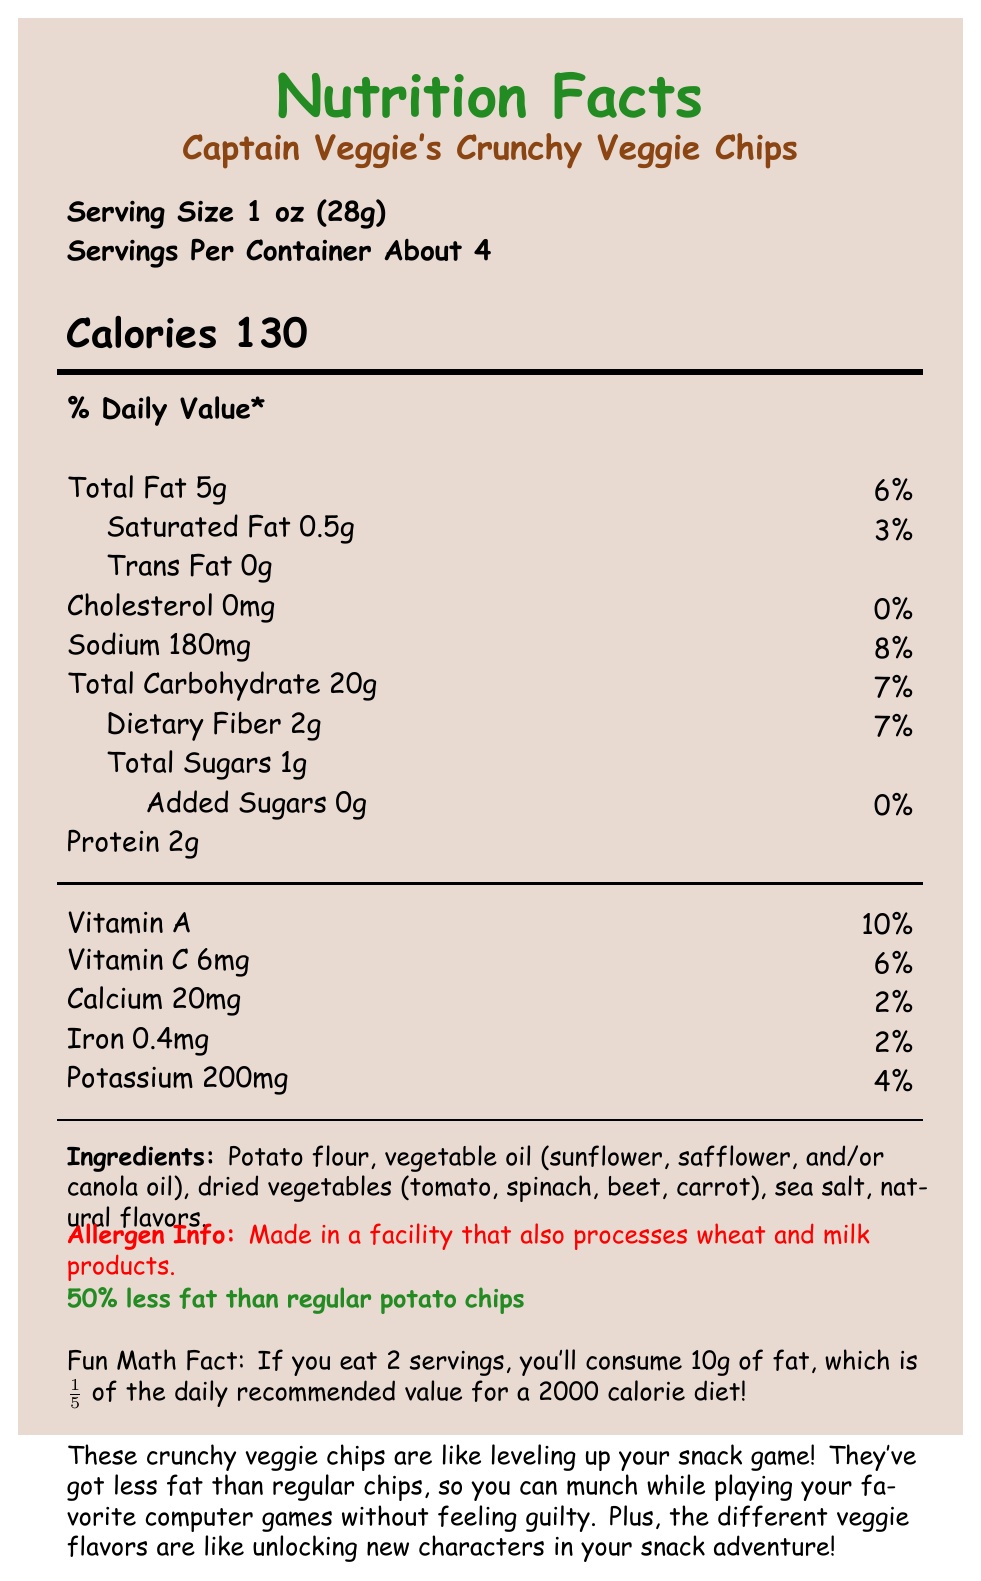what is the serving size? The serving size is explicitly mentioned under the "Serving Size" section.
Answer: 1 oz (28g) how many calories are there per serving? The number of calories per serving is stated next to "Calories."
Answer: 130 how much total fat is in one serving? The amount of total fat per serving is listed as "Total Fat 5g" in the document.
Answer: 5g is there any trans fat in these veggie chips? The document states "Trans Fat 0g," meaning there are no trans fats.
Answer: No what is the % Daily Value of sodium in one serving? The % Daily Value for sodium is given as "8%" in the document.
Answer: 8% how much dietary fiber is in one serving? The dietary fiber content is listed as "Dietary Fiber 2g" on the document.
Answer: 2g which ingredient appears first in the ingredients list? The first ingredient listed is "Potato flour."
Answer: Potato flour do these veggie chips contain milk products? The allergen info states that the chips are made in a facility that also processes milk products.
Answer: Yes how many servings does the entire container have? The document mentions "Servings Per Container About 4."
Answer: About 4 what is the total carbohydrate content per serving? The total carbohydrate content is listed as "Total Carbohydrate 20g."
Answer: 20g which nutrient has the highest % Daily Value? A. Vitamin A B. Protein C. Calcium D. Iron Vitamin A has the highest % Daily Value of 10%.
Answer: A. Vitamin A which of these is not an ingredient in the veggie chips? I. Tomato II. Beetroot III. Sugar IV. Carrot Sugar is not listed among the ingredients, but tomato, beetroot, and carrot are.
Answer: III. Sugar are these veggie chips healthier than regular potato chips in terms of fat content? The document claims "50% less fat than regular potato chips."
Answer: Yes summarize the key points of this nutrition label. This summary covers the main nutritional details, ingredients, and comparisons to regular chips, along with the allergen information.
Answer: The label provides essential nutritional information for Captain Veggie's Crunchy Veggie Chips. Each serving size is 1 oz (28g), with about 4 servings per container. Each serving contains 130 calories and 5g of total fat, which is 50% less than regular potato chips. The chips are made with potato flour, vegetable oils, and dried vegetables. They provide various nutrients, including vitamin A, vitamin C, calcium, iron, and potassium. The chips are produced in a facility that processes wheat and milk products. what is the mascot's name for these veggie chips? The document includes a kid-friendly description that mentions the character mascot, "Captain Veggie."
Answer: Captain Veggie if you eat 2 servings, what percent of the daily recommended value for fat will you consume? The fun math fact indicates that consuming 2 servings results in 10g of fat, which is 1/5 (or 20%) of the daily recommended value for a 2000 calorie diet.
Answer: 20% what is the recommended daily value of calcium for kids? The document provides the % Daily Value of calcium for the veggie chips, but it doesn't provide the full recommended daily value for kids.
Answer: Not enough information 